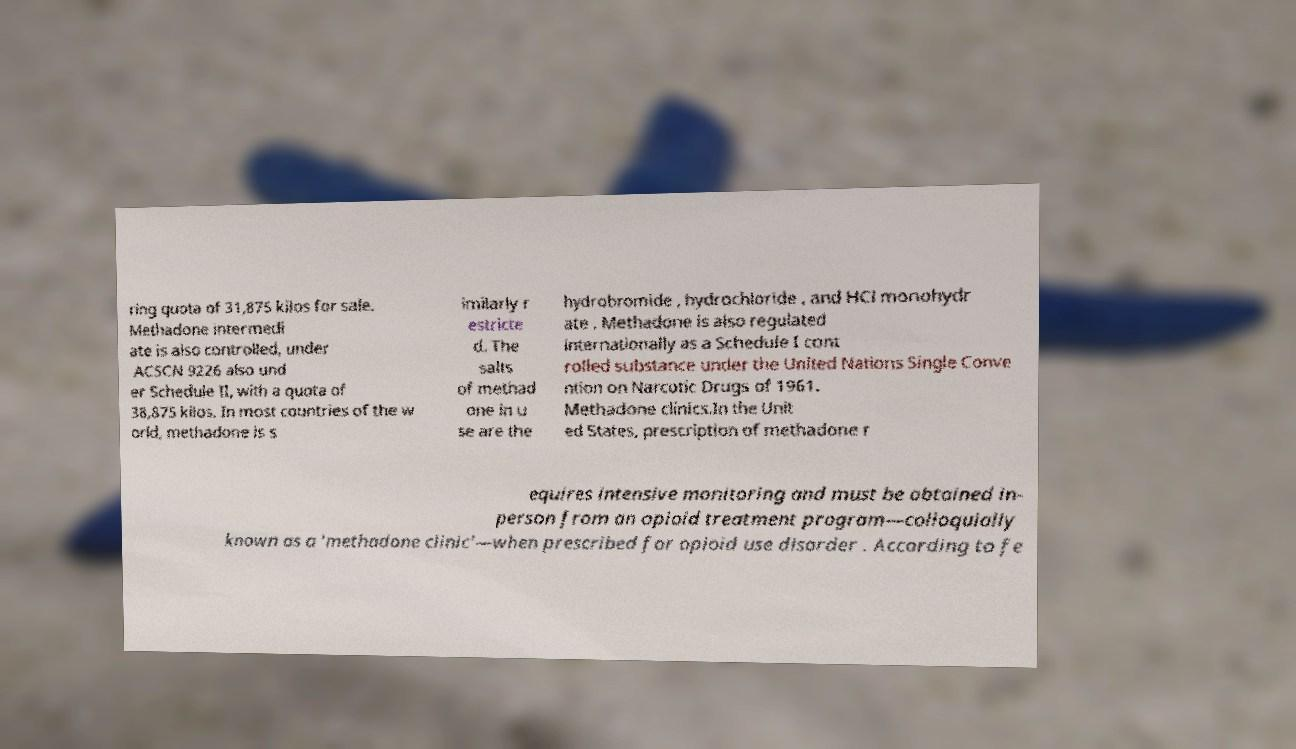There's text embedded in this image that I need extracted. Can you transcribe it verbatim? ring quota of 31,875 kilos for sale. Methadone intermedi ate is also controlled, under ACSCN 9226 also und er Schedule II, with a quota of 38,875 kilos. In most countries of the w orld, methadone is s imilarly r estricte d. The salts of methad one in u se are the hydrobromide , hydrochloride , and HCl monohydr ate . Methadone is also regulated internationally as a Schedule I cont rolled substance under the United Nations Single Conve ntion on Narcotic Drugs of 1961. Methadone clinics.In the Unit ed States, prescription of methadone r equires intensive monitoring and must be obtained in- person from an opioid treatment program—colloquially known as a 'methadone clinic'—when prescribed for opioid use disorder . According to fe 